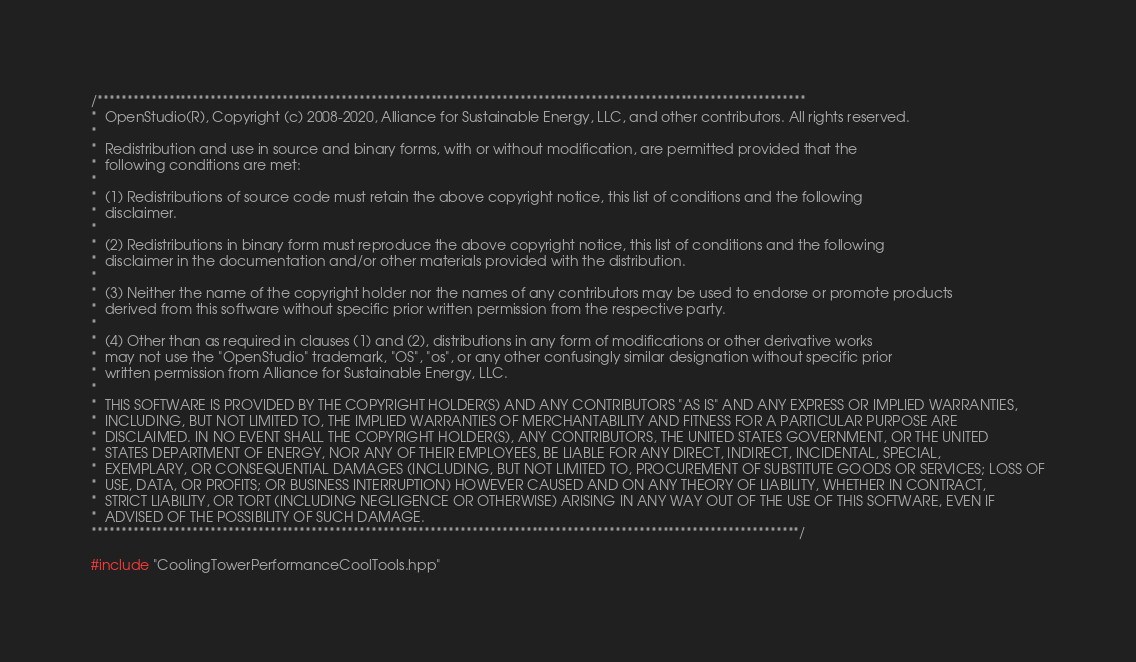<code> <loc_0><loc_0><loc_500><loc_500><_C++_>/***********************************************************************************************************************
*  OpenStudio(R), Copyright (c) 2008-2020, Alliance for Sustainable Energy, LLC, and other contributors. All rights reserved.
*
*  Redistribution and use in source and binary forms, with or without modification, are permitted provided that the
*  following conditions are met:
*
*  (1) Redistributions of source code must retain the above copyright notice, this list of conditions and the following
*  disclaimer.
*
*  (2) Redistributions in binary form must reproduce the above copyright notice, this list of conditions and the following
*  disclaimer in the documentation and/or other materials provided with the distribution.
*
*  (3) Neither the name of the copyright holder nor the names of any contributors may be used to endorse or promote products
*  derived from this software without specific prior written permission from the respective party.
*
*  (4) Other than as required in clauses (1) and (2), distributions in any form of modifications or other derivative works
*  may not use the "OpenStudio" trademark, "OS", "os", or any other confusingly similar designation without specific prior
*  written permission from Alliance for Sustainable Energy, LLC.
*
*  THIS SOFTWARE IS PROVIDED BY THE COPYRIGHT HOLDER(S) AND ANY CONTRIBUTORS "AS IS" AND ANY EXPRESS OR IMPLIED WARRANTIES,
*  INCLUDING, BUT NOT LIMITED TO, THE IMPLIED WARRANTIES OF MERCHANTABILITY AND FITNESS FOR A PARTICULAR PURPOSE ARE
*  DISCLAIMED. IN NO EVENT SHALL THE COPYRIGHT HOLDER(S), ANY CONTRIBUTORS, THE UNITED STATES GOVERNMENT, OR THE UNITED
*  STATES DEPARTMENT OF ENERGY, NOR ANY OF THEIR EMPLOYEES, BE LIABLE FOR ANY DIRECT, INDIRECT, INCIDENTAL, SPECIAL,
*  EXEMPLARY, OR CONSEQUENTIAL DAMAGES (INCLUDING, BUT NOT LIMITED TO, PROCUREMENT OF SUBSTITUTE GOODS OR SERVICES; LOSS OF
*  USE, DATA, OR PROFITS; OR BUSINESS INTERRUPTION) HOWEVER CAUSED AND ON ANY THEORY OF LIABILITY, WHETHER IN CONTRACT,
*  STRICT LIABILITY, OR TORT (INCLUDING NEGLIGENCE OR OTHERWISE) ARISING IN ANY WAY OUT OF THE USE OF THIS SOFTWARE, EVEN IF
*  ADVISED OF THE POSSIBILITY OF SUCH DAMAGE.
***********************************************************************************************************************/

#include "CoolingTowerPerformanceCoolTools.hpp"</code> 